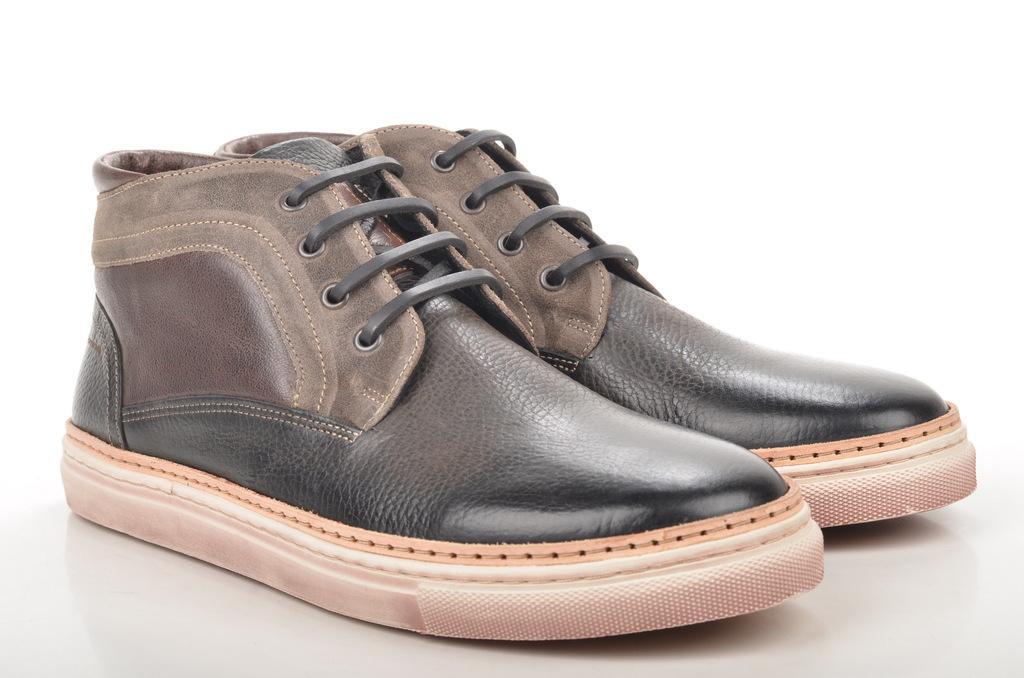In one or two sentences, can you explain what this image depicts? In this picture we can see shoes on the white platform. In the background of the image it is white. 